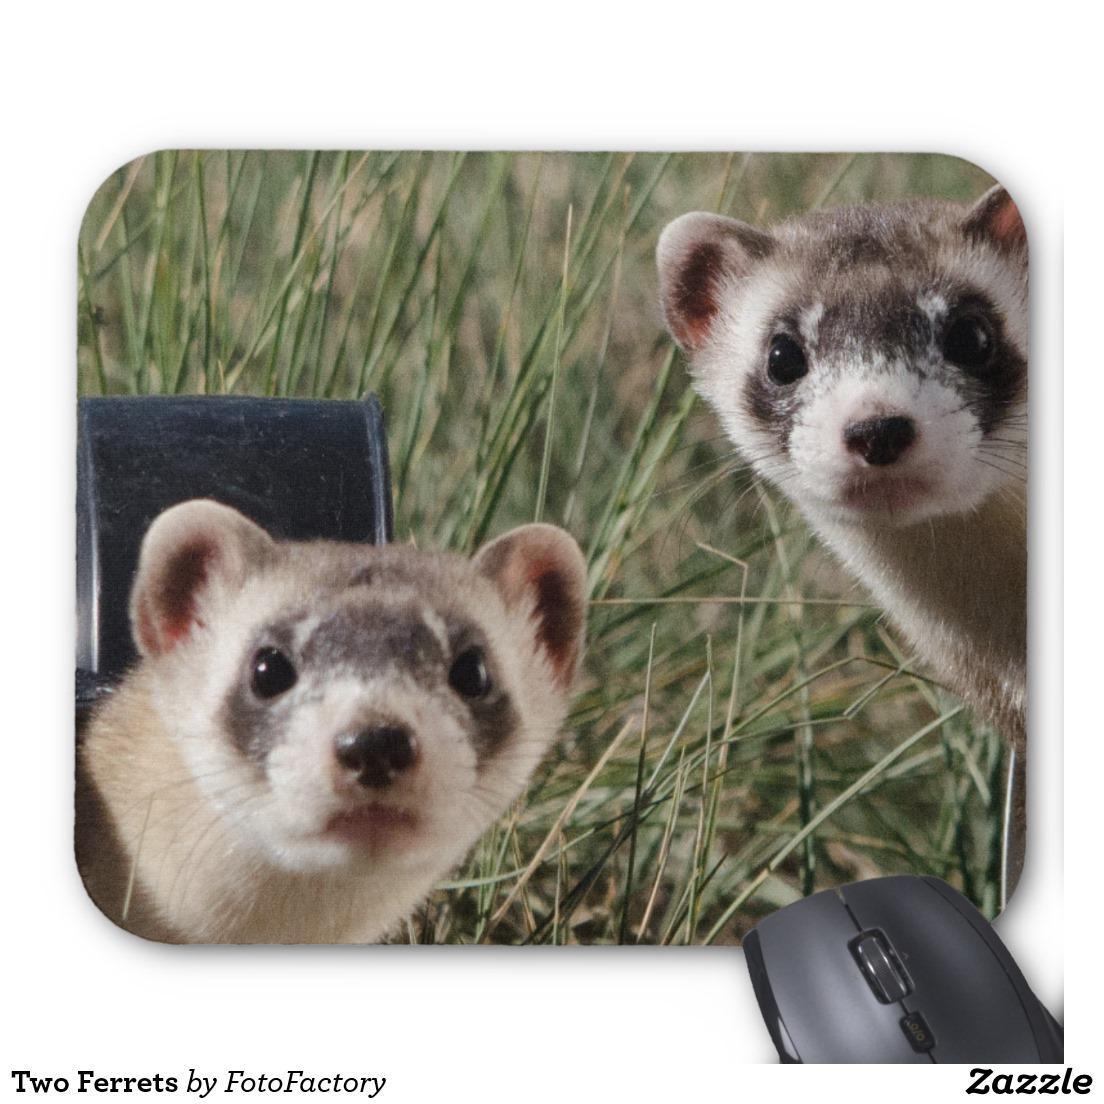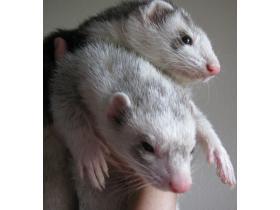The first image is the image on the left, the second image is the image on the right. Evaluate the accuracy of this statement regarding the images: "Each image contains a pair of ferrets that are brown and light colored and grouped together.". Is it true? Answer yes or no. No. 